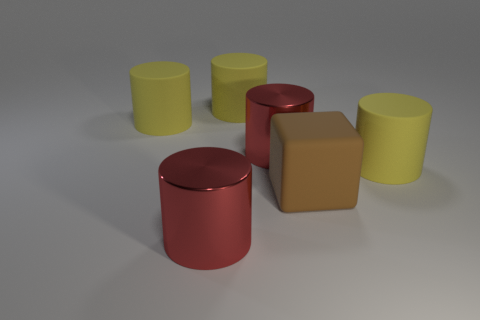What color is the matte cube?
Give a very brief answer. Brown. What is the color of the large metal thing left of the large red metallic object behind the matte cube?
Keep it short and to the point. Red. Is there a big yellow thing made of the same material as the brown cube?
Ensure brevity in your answer.  Yes. What material is the red cylinder behind the thing that is in front of the brown object?
Keep it short and to the point. Metal. The large brown rubber thing has what shape?
Your response must be concise. Cube. Is the number of red metallic objects less than the number of brown matte things?
Your answer should be compact. No. Is there any other thing that has the same size as the brown thing?
Provide a succinct answer. Yes. Are there more big brown metal cylinders than yellow matte objects?
Your answer should be very brief. No. How many other objects are the same color as the matte block?
Provide a succinct answer. 0. Do the brown thing and the large thing to the right of the big brown rubber block have the same material?
Provide a short and direct response. Yes. 